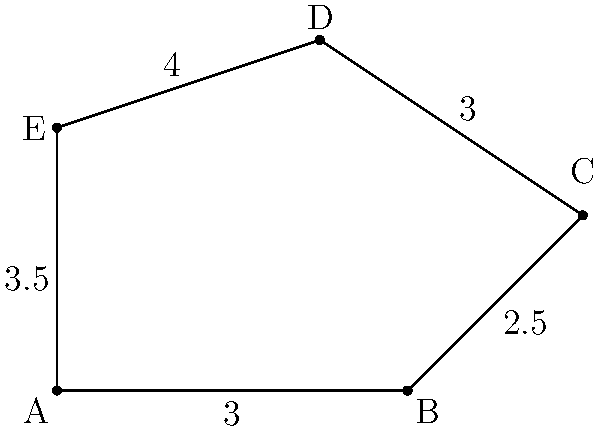Hey, check out this cool polygon I found in the app! Can you help me figure out its perimeter? The side lengths are given, but it's not a regular shape. How can we calculate the total distance around it? Sure! Let's solve this step-by-step:

1) First, we need to identify all the side lengths of the polygon:
   - Side AB = 3
   - Side BC = 2.5
   - Side CD = 3
   - Side DE = 4
   - Side EA = 3.5

2) To find the perimeter, we simply need to add up all these side lengths:

   $$\text{Perimeter} = AB + BC + CD + DE + EA$$

3) Let's substitute the values:

   $$\text{Perimeter} = 3 + 2.5 + 3 + 4 + 3.5$$

4) Now, we just need to perform the addition:

   $$\text{Perimeter} = 16$$

So, the total distance around the polygon (its perimeter) is 16 units.
Answer: $16$ units 